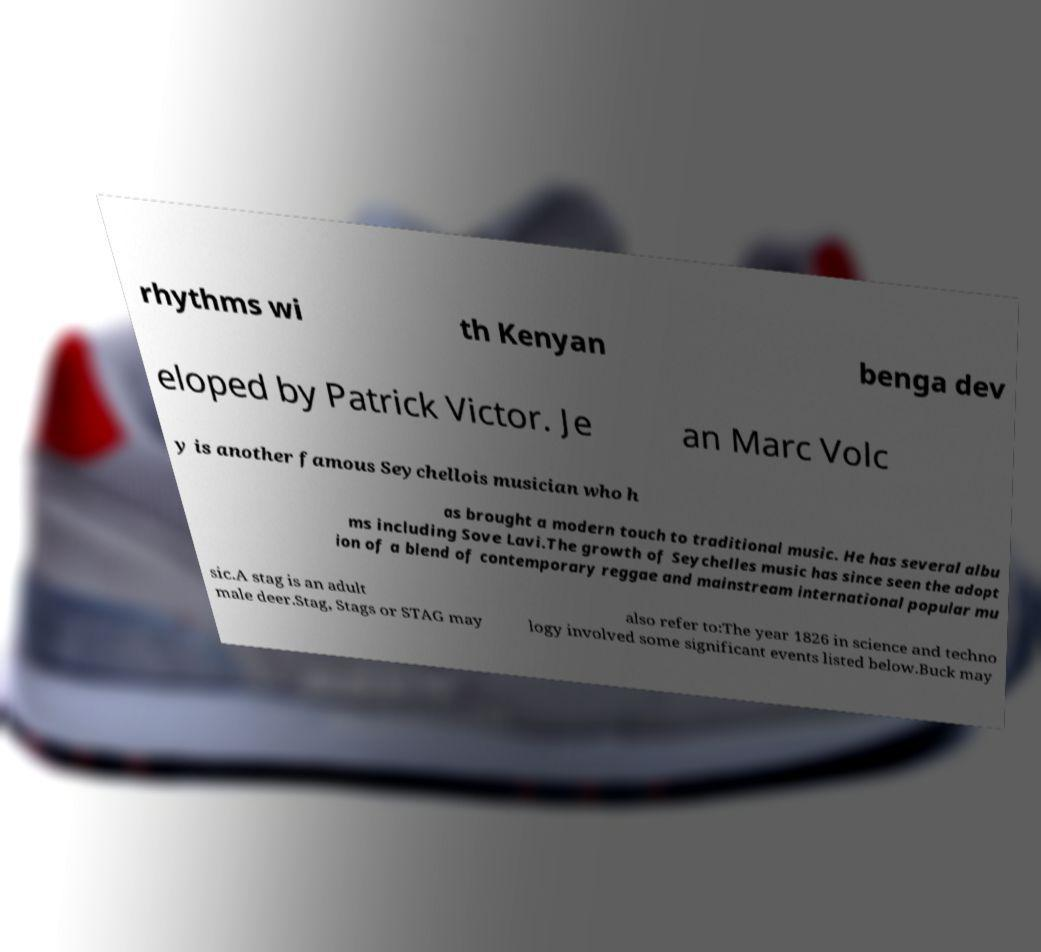Could you assist in decoding the text presented in this image and type it out clearly? rhythms wi th Kenyan benga dev eloped by Patrick Victor. Je an Marc Volc y is another famous Seychellois musician who h as brought a modern touch to traditional music. He has several albu ms including Sove Lavi.The growth of Seychelles music has since seen the adopt ion of a blend of contemporary reggae and mainstream international popular mu sic.A stag is an adult male deer.Stag, Stags or STAG may also refer to:The year 1826 in science and techno logy involved some significant events listed below.Buck may 